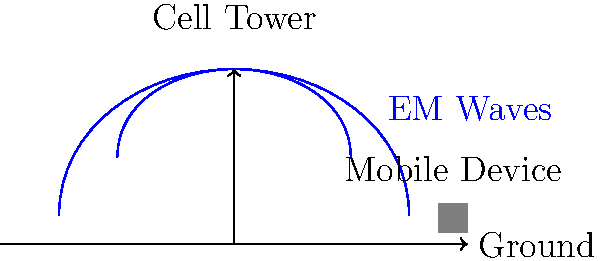In the context of mobile media consumption in the Baltic region, how does the electromagnetic wave propagation pattern from a cell phone tower affect signal strength and coverage area? Consider the impact on streaming services offered by former MTG subsidiaries. To understand the electromagnetic wave propagation patterns of cell phone towers and their impact on mobile media consumption, let's break it down step-by-step:

1. Electromagnetic Wave Basics:
   - Cell towers emit electromagnetic (EM) waves in the radio frequency spectrum.
   - These waves propagate in all directions from the tower, as shown in the diagram.

2. Inverse Square Law:
   - The signal strength decreases according to the inverse square law: $S \propto \frac{1}{d^2}$
   - Where $S$ is the signal strength and $d$ is the distance from the tower.

3. Fresnel Zones:
   - The area between the tower and the mobile device is divided into Fresnel zones.
   - The first Fresnel zone is most critical for signal strength.
   - The radius of the first Fresnel zone at its widest point is given by:
     $r = \sqrt{\frac{\lambda d}{4}}$
   - Where $r$ is the radius, $\lambda$ is the wavelength, and $d$ is the distance between the tower and device.

4. Obstacles and Terrain:
   - Buildings, trees, and terrain features can obstruct EM waves.
   - This can create "shadow zones" with weak or no signal.

5. Frequency Bands:
   - Different frequency bands have different propagation characteristics.
   - Lower frequencies (e.g., 700 MHz) travel further and penetrate buildings better.
   - Higher frequencies (e.g., 2600 MHz) offer more bandwidth but have shorter range.

6. Impact on Streaming Services:
   - Strong, consistent signals are crucial for streaming media.
   - Weaker signals can result in buffering, lower video quality, or service interruptions.
   - This directly affects user experience for streaming services offered by former MTG subsidiaries.

7. Coverage Area:
   - The effective coverage area is determined by the combination of these factors.
   - Network planners must optimize tower placement and configuration to maximize coverage and capacity.

8. Evolution of Network Technology:
   - Newer technologies (4G, 5G) use advanced techniques like MIMO (Multiple Input Multiple Output) to improve signal propagation and capacity.
   - This has allowed for better mobile media consumption experiences over time.

In the Baltic region, these factors would have influenced the development and performance of mobile networks, directly impacting the delivery of streaming services by media companies evolved from MTG's operations.
Answer: Inverse square law governs signal strength; obstacles create shadow zones; frequency affects range and penetration; strong signals crucial for streaming quality. 